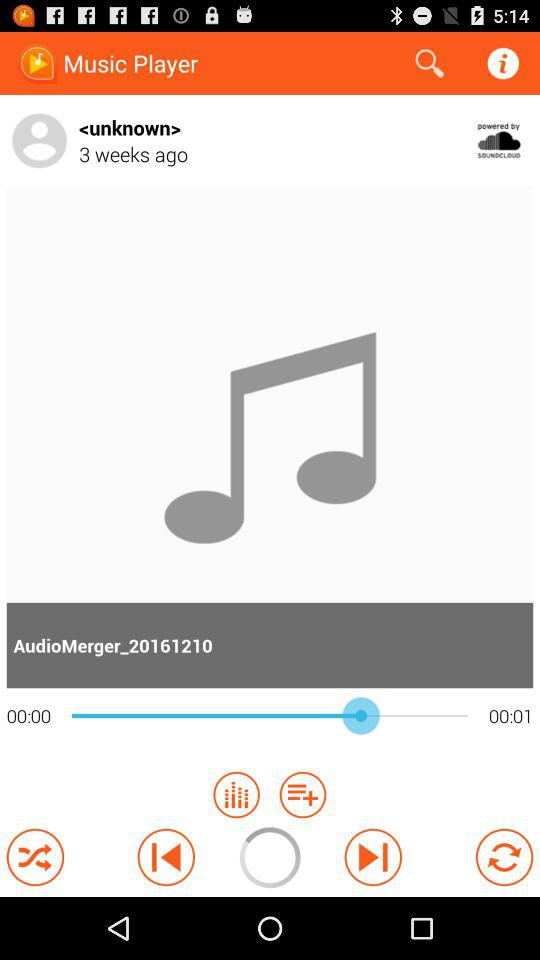What is the duration of the audio? The duration of the audio is 00:01. 